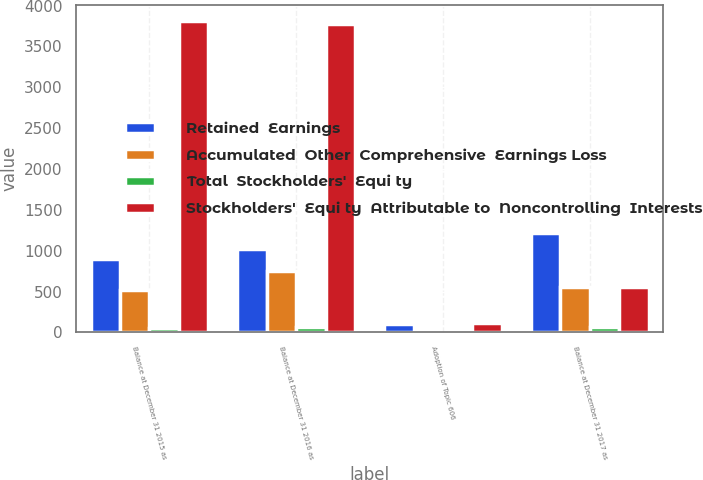Convert chart to OTSL. <chart><loc_0><loc_0><loc_500><loc_500><stacked_bar_chart><ecel><fcel>Balance at December 31 2015 as<fcel>Balance at December 31 2016 as<fcel>Adoption of Topic 606<fcel>Balance at December 31 2017 as<nl><fcel>Retained  Earnings<fcel>899.8<fcel>1024.1<fcel>107.7<fcel>1221.8<nl><fcel>Accumulated  Other  Comprehensive  Earnings Loss<fcel>522.5<fcel>756.6<fcel>7<fcel>555.4<nl><fcel>Total  Stockholders'  Equi ty<fcel>52.1<fcel>64.2<fcel>5<fcel>64.1<nl><fcel>Stockholders'  Equi ty  Attributable to  Noncontrolling  Interests<fcel>3815.7<fcel>3775.5<fcel>119.7<fcel>559.9<nl></chart> 